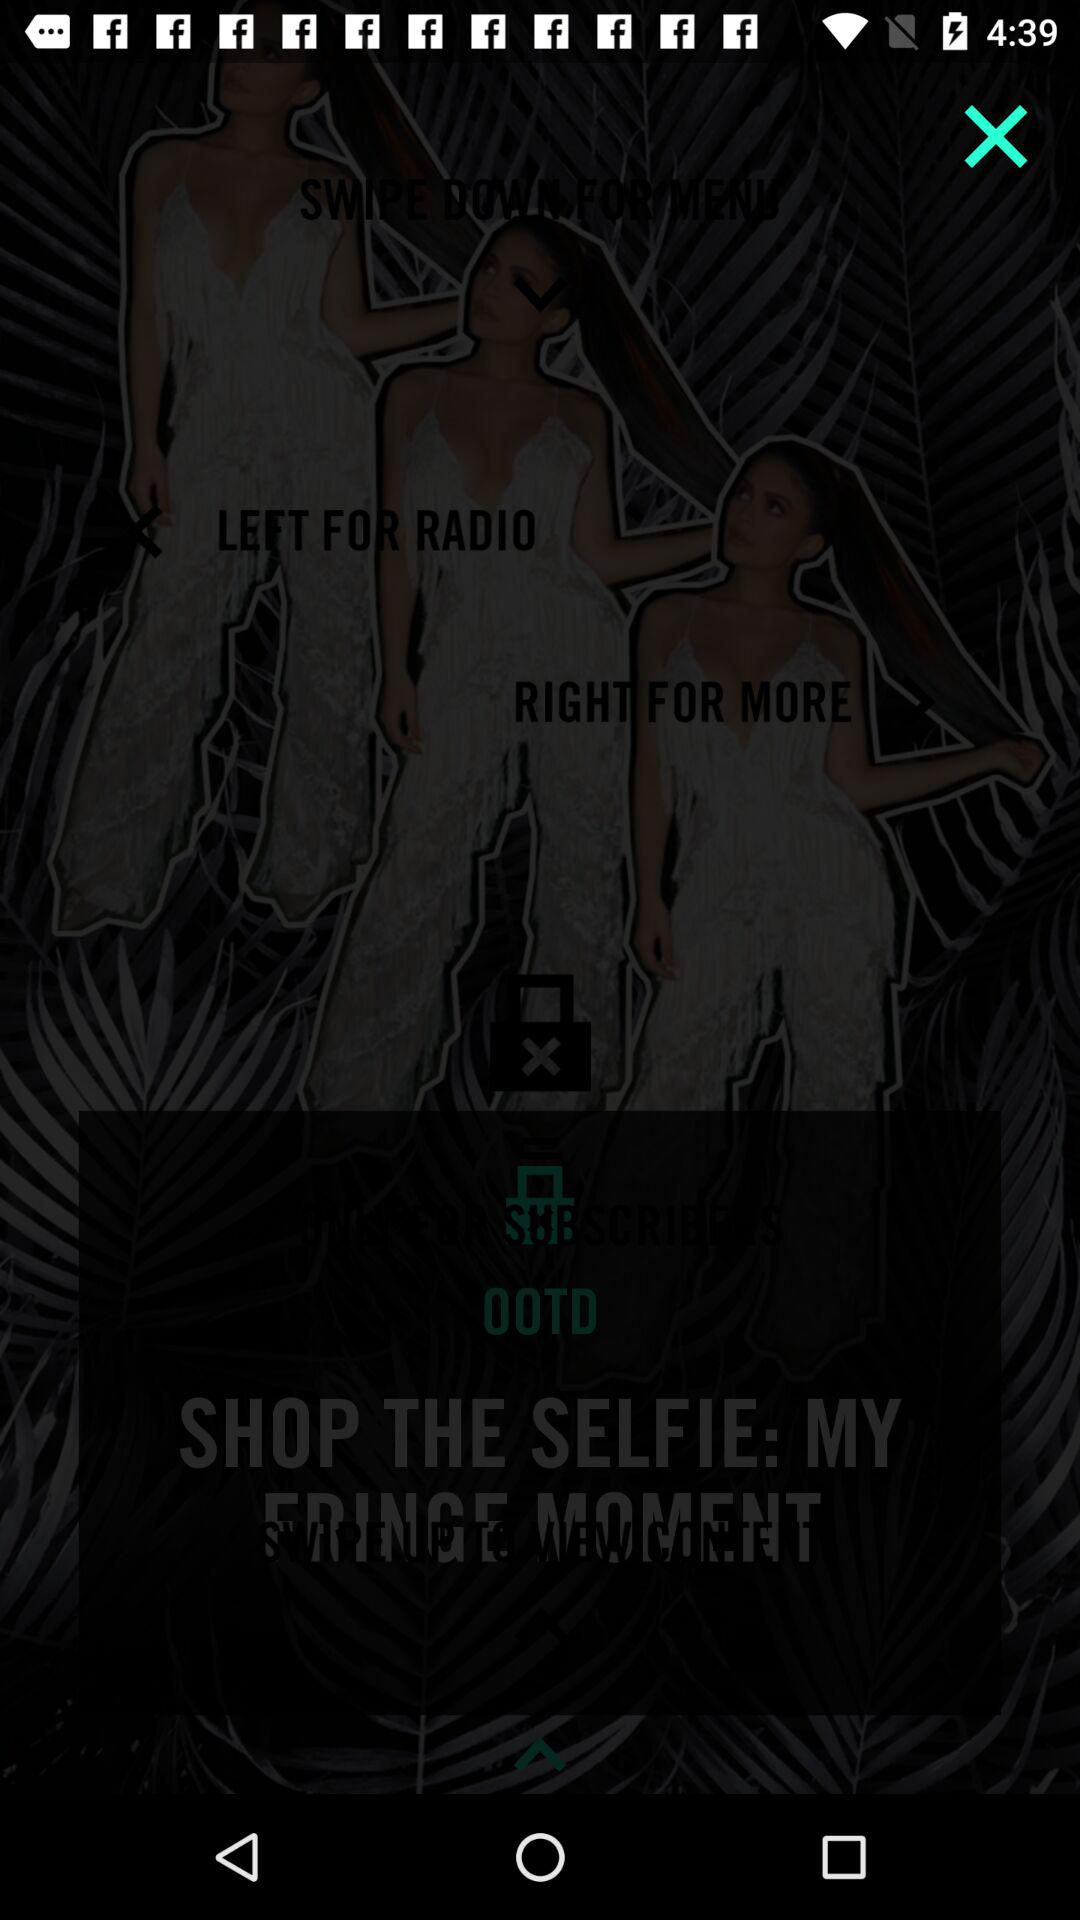What is the name of the application? The name of the application is "OOTD". 